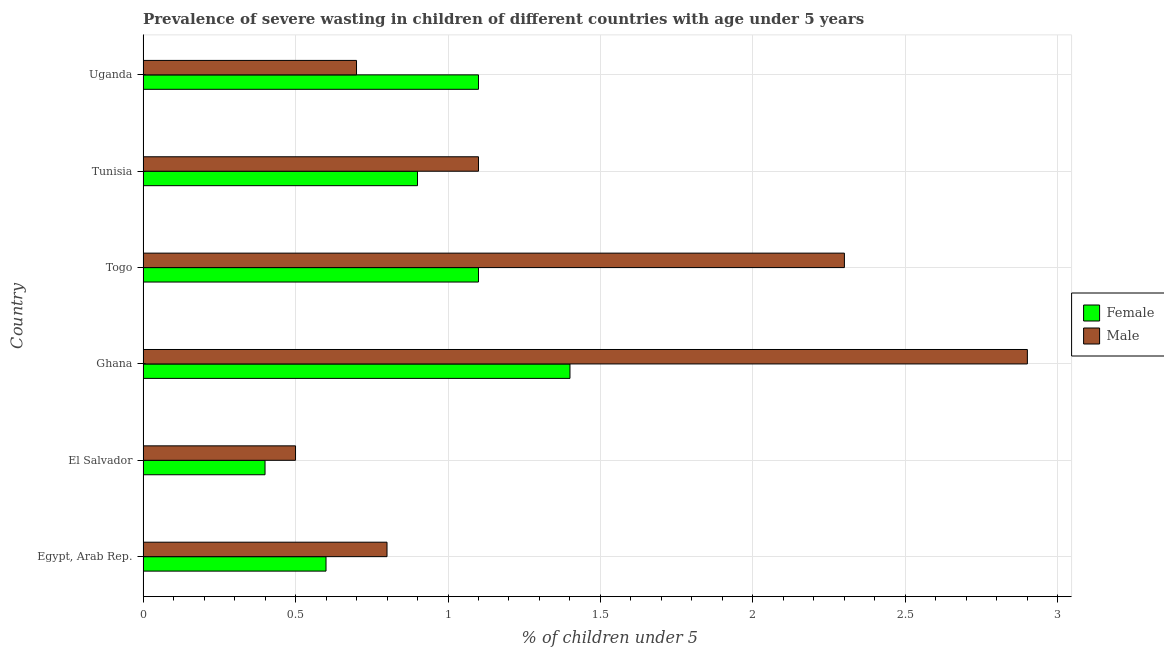How many different coloured bars are there?
Your answer should be very brief. 2. How many groups of bars are there?
Your answer should be very brief. 6. What is the label of the 5th group of bars from the top?
Offer a terse response. El Salvador. In how many cases, is the number of bars for a given country not equal to the number of legend labels?
Offer a terse response. 0. What is the percentage of undernourished female children in Egypt, Arab Rep.?
Ensure brevity in your answer.  0.6. Across all countries, what is the maximum percentage of undernourished female children?
Ensure brevity in your answer.  1.4. Across all countries, what is the minimum percentage of undernourished female children?
Your answer should be very brief. 0.4. In which country was the percentage of undernourished male children maximum?
Your answer should be compact. Ghana. In which country was the percentage of undernourished male children minimum?
Provide a succinct answer. El Salvador. What is the total percentage of undernourished female children in the graph?
Offer a very short reply. 5.5. What is the difference between the percentage of undernourished male children in Togo and that in Tunisia?
Ensure brevity in your answer.  1.2. What is the difference between the percentage of undernourished female children in Togo and the percentage of undernourished male children in Uganda?
Give a very brief answer. 0.4. What is the average percentage of undernourished female children per country?
Give a very brief answer. 0.92. In how many countries, is the percentage of undernourished male children greater than 2.8 %?
Offer a terse response. 1. What is the ratio of the percentage of undernourished female children in El Salvador to that in Togo?
Offer a terse response. 0.36. Is the difference between the percentage of undernourished female children in El Salvador and Ghana greater than the difference between the percentage of undernourished male children in El Salvador and Ghana?
Offer a terse response. Yes. What is the difference between the highest and the lowest percentage of undernourished female children?
Your answer should be compact. 1. In how many countries, is the percentage of undernourished female children greater than the average percentage of undernourished female children taken over all countries?
Your answer should be compact. 3. Are all the bars in the graph horizontal?
Offer a terse response. Yes. Where does the legend appear in the graph?
Offer a very short reply. Center right. What is the title of the graph?
Your response must be concise. Prevalence of severe wasting in children of different countries with age under 5 years. Does "Money lenders" appear as one of the legend labels in the graph?
Offer a very short reply. No. What is the label or title of the X-axis?
Offer a very short reply.  % of children under 5. What is the label or title of the Y-axis?
Keep it short and to the point. Country. What is the  % of children under 5 of Female in Egypt, Arab Rep.?
Provide a succinct answer. 0.6. What is the  % of children under 5 in Male in Egypt, Arab Rep.?
Ensure brevity in your answer.  0.8. What is the  % of children under 5 of Female in El Salvador?
Your answer should be compact. 0.4. What is the  % of children under 5 in Male in El Salvador?
Offer a very short reply. 0.5. What is the  % of children under 5 in Female in Ghana?
Provide a succinct answer. 1.4. What is the  % of children under 5 of Male in Ghana?
Offer a terse response. 2.9. What is the  % of children under 5 in Female in Togo?
Your answer should be very brief. 1.1. What is the  % of children under 5 of Male in Togo?
Give a very brief answer. 2.3. What is the  % of children under 5 in Female in Tunisia?
Offer a terse response. 0.9. What is the  % of children under 5 of Male in Tunisia?
Your answer should be very brief. 1.1. What is the  % of children under 5 of Female in Uganda?
Give a very brief answer. 1.1. What is the  % of children under 5 of Male in Uganda?
Give a very brief answer. 0.7. Across all countries, what is the maximum  % of children under 5 of Female?
Your answer should be very brief. 1.4. Across all countries, what is the maximum  % of children under 5 of Male?
Keep it short and to the point. 2.9. Across all countries, what is the minimum  % of children under 5 of Female?
Offer a terse response. 0.4. Across all countries, what is the minimum  % of children under 5 of Male?
Keep it short and to the point. 0.5. What is the total  % of children under 5 of Female in the graph?
Give a very brief answer. 5.5. What is the total  % of children under 5 of Male in the graph?
Offer a very short reply. 8.3. What is the difference between the  % of children under 5 of Female in Egypt, Arab Rep. and that in El Salvador?
Offer a terse response. 0.2. What is the difference between the  % of children under 5 in Female in Egypt, Arab Rep. and that in Togo?
Your response must be concise. -0.5. What is the difference between the  % of children under 5 of Female in Egypt, Arab Rep. and that in Tunisia?
Offer a terse response. -0.3. What is the difference between the  % of children under 5 of Male in Egypt, Arab Rep. and that in Tunisia?
Your response must be concise. -0.3. What is the difference between the  % of children under 5 in Female in Egypt, Arab Rep. and that in Uganda?
Your response must be concise. -0.5. What is the difference between the  % of children under 5 in Male in Egypt, Arab Rep. and that in Uganda?
Offer a terse response. 0.1. What is the difference between the  % of children under 5 in Male in El Salvador and that in Ghana?
Keep it short and to the point. -2.4. What is the difference between the  % of children under 5 in Female in El Salvador and that in Togo?
Your answer should be compact. -0.7. What is the difference between the  % of children under 5 of Female in El Salvador and that in Tunisia?
Your answer should be compact. -0.5. What is the difference between the  % of children under 5 of Male in El Salvador and that in Tunisia?
Your response must be concise. -0.6. What is the difference between the  % of children under 5 of Female in Ghana and that in Togo?
Provide a short and direct response. 0.3. What is the difference between the  % of children under 5 of Male in Ghana and that in Togo?
Provide a succinct answer. 0.6. What is the difference between the  % of children under 5 in Male in Ghana and that in Tunisia?
Your response must be concise. 1.8. What is the difference between the  % of children under 5 in Female in Ghana and that in Uganda?
Your answer should be very brief. 0.3. What is the difference between the  % of children under 5 of Male in Ghana and that in Uganda?
Provide a succinct answer. 2.2. What is the difference between the  % of children under 5 in Female in Togo and that in Tunisia?
Your answer should be compact. 0.2. What is the difference between the  % of children under 5 in Female in Tunisia and that in Uganda?
Provide a succinct answer. -0.2. What is the difference between the  % of children under 5 in Male in Tunisia and that in Uganda?
Provide a short and direct response. 0.4. What is the difference between the  % of children under 5 in Female in Egypt, Arab Rep. and the  % of children under 5 in Male in El Salvador?
Keep it short and to the point. 0.1. What is the difference between the  % of children under 5 of Female in Egypt, Arab Rep. and the  % of children under 5 of Male in Tunisia?
Offer a terse response. -0.5. What is the difference between the  % of children under 5 in Female in El Salvador and the  % of children under 5 in Male in Ghana?
Your answer should be compact. -2.5. What is the difference between the  % of children under 5 of Female in El Salvador and the  % of children under 5 of Male in Togo?
Give a very brief answer. -1.9. What is the difference between the  % of children under 5 in Female in El Salvador and the  % of children under 5 in Male in Uganda?
Your answer should be very brief. -0.3. What is the difference between the  % of children under 5 of Female in Ghana and the  % of children under 5 of Male in Tunisia?
Ensure brevity in your answer.  0.3. What is the difference between the  % of children under 5 of Female in Togo and the  % of children under 5 of Male in Tunisia?
Ensure brevity in your answer.  0. What is the difference between the  % of children under 5 in Female in Togo and the  % of children under 5 in Male in Uganda?
Your response must be concise. 0.4. What is the difference between the  % of children under 5 in Female in Tunisia and the  % of children under 5 in Male in Uganda?
Offer a very short reply. 0.2. What is the average  % of children under 5 of Male per country?
Your answer should be compact. 1.38. What is the difference between the  % of children under 5 in Female and  % of children under 5 in Male in Egypt, Arab Rep.?
Make the answer very short. -0.2. What is the ratio of the  % of children under 5 of Male in Egypt, Arab Rep. to that in El Salvador?
Ensure brevity in your answer.  1.6. What is the ratio of the  % of children under 5 of Female in Egypt, Arab Rep. to that in Ghana?
Give a very brief answer. 0.43. What is the ratio of the  % of children under 5 of Male in Egypt, Arab Rep. to that in Ghana?
Your answer should be compact. 0.28. What is the ratio of the  % of children under 5 of Female in Egypt, Arab Rep. to that in Togo?
Keep it short and to the point. 0.55. What is the ratio of the  % of children under 5 of Male in Egypt, Arab Rep. to that in Togo?
Your answer should be very brief. 0.35. What is the ratio of the  % of children under 5 of Female in Egypt, Arab Rep. to that in Tunisia?
Your answer should be very brief. 0.67. What is the ratio of the  % of children under 5 in Male in Egypt, Arab Rep. to that in Tunisia?
Ensure brevity in your answer.  0.73. What is the ratio of the  % of children under 5 of Female in Egypt, Arab Rep. to that in Uganda?
Provide a short and direct response. 0.55. What is the ratio of the  % of children under 5 in Female in El Salvador to that in Ghana?
Your answer should be compact. 0.29. What is the ratio of the  % of children under 5 in Male in El Salvador to that in Ghana?
Your answer should be compact. 0.17. What is the ratio of the  % of children under 5 of Female in El Salvador to that in Togo?
Give a very brief answer. 0.36. What is the ratio of the  % of children under 5 in Male in El Salvador to that in Togo?
Keep it short and to the point. 0.22. What is the ratio of the  % of children under 5 of Female in El Salvador to that in Tunisia?
Keep it short and to the point. 0.44. What is the ratio of the  % of children under 5 of Male in El Salvador to that in Tunisia?
Ensure brevity in your answer.  0.45. What is the ratio of the  % of children under 5 of Female in El Salvador to that in Uganda?
Offer a terse response. 0.36. What is the ratio of the  % of children under 5 of Male in El Salvador to that in Uganda?
Make the answer very short. 0.71. What is the ratio of the  % of children under 5 in Female in Ghana to that in Togo?
Your answer should be very brief. 1.27. What is the ratio of the  % of children under 5 of Male in Ghana to that in Togo?
Ensure brevity in your answer.  1.26. What is the ratio of the  % of children under 5 of Female in Ghana to that in Tunisia?
Your answer should be compact. 1.56. What is the ratio of the  % of children under 5 of Male in Ghana to that in Tunisia?
Provide a succinct answer. 2.64. What is the ratio of the  % of children under 5 in Female in Ghana to that in Uganda?
Make the answer very short. 1.27. What is the ratio of the  % of children under 5 in Male in Ghana to that in Uganda?
Keep it short and to the point. 4.14. What is the ratio of the  % of children under 5 in Female in Togo to that in Tunisia?
Offer a very short reply. 1.22. What is the ratio of the  % of children under 5 in Male in Togo to that in Tunisia?
Your response must be concise. 2.09. What is the ratio of the  % of children under 5 in Female in Togo to that in Uganda?
Provide a succinct answer. 1. What is the ratio of the  % of children under 5 of Male in Togo to that in Uganda?
Ensure brevity in your answer.  3.29. What is the ratio of the  % of children under 5 of Female in Tunisia to that in Uganda?
Provide a succinct answer. 0.82. What is the ratio of the  % of children under 5 of Male in Tunisia to that in Uganda?
Give a very brief answer. 1.57. What is the difference between the highest and the second highest  % of children under 5 in Male?
Your response must be concise. 0.6. 